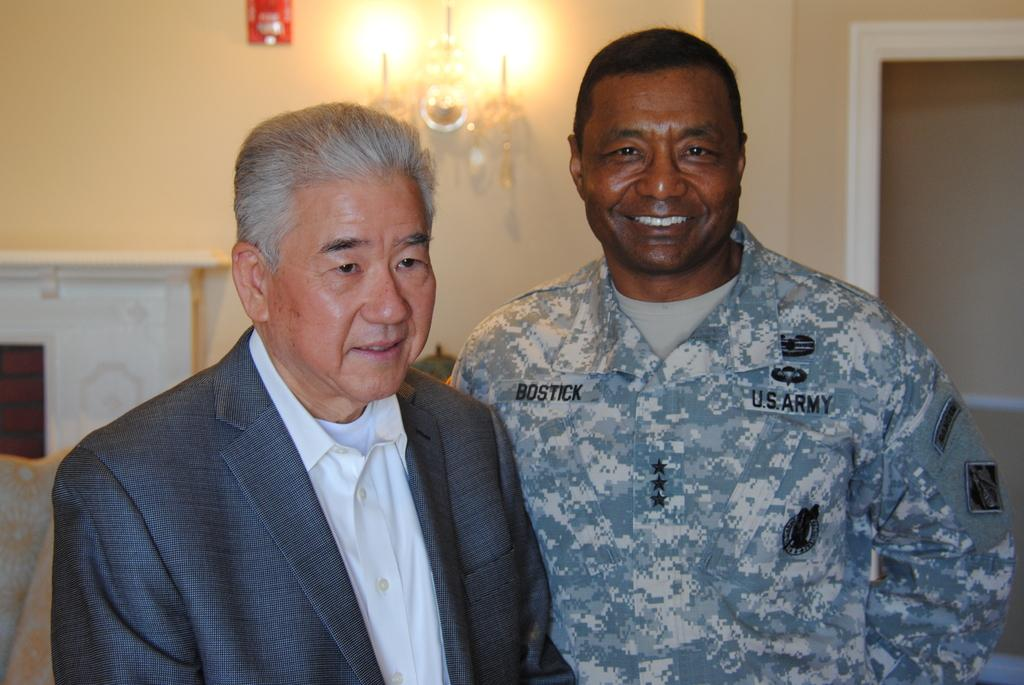How many people are in the image? There are two men in the image. What are the men wearing? The men are wearing clothes. What expression do the men have? The men are smiling. What can be seen in the background of the image? There is a wall in the background of the image. How would you describe the background in the image? The background is slightly blurred. What type of bear can be seen reading a book in the image? There is no bear or book present in the image; it features two men smiling. What border is visible in the image? There is no border visible in the image; it is a photograph of two men and a background. 